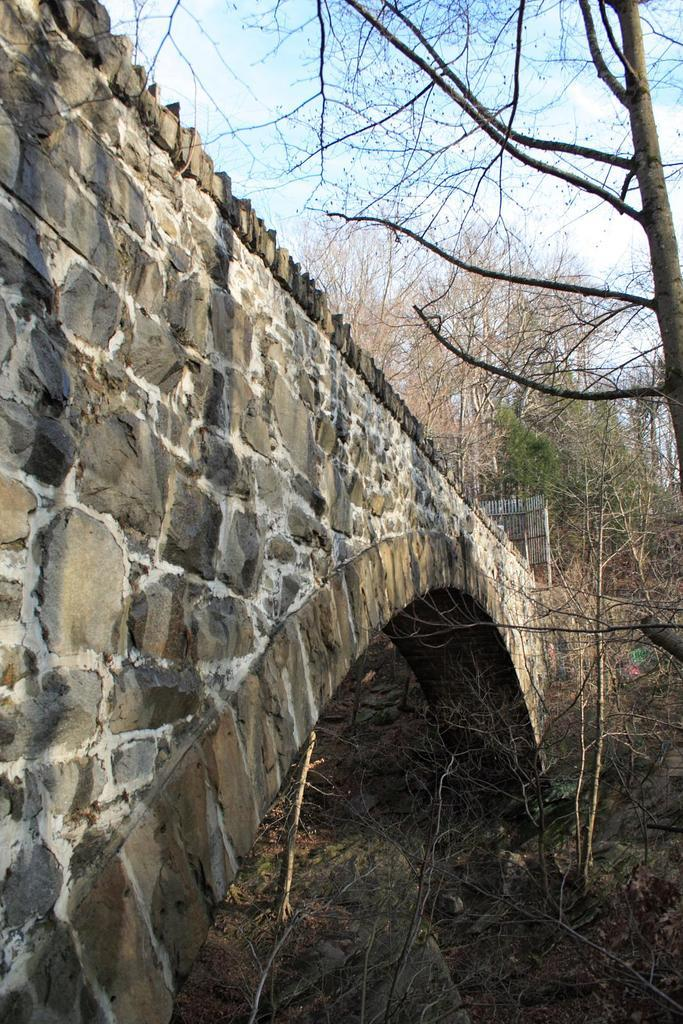What type of vegetation can be seen in the image? There are trees in the image. What can be seen beneath the trees? The ground is visible in the image. Are there any objects on the ground? Yes, there are objects on the ground. What structure can be seen crossing over a body of water in the image? There is a bridge in the image. What is visible above the trees and objects in the image? The sky is visible in the image. Is there any barrier or enclosure visible in the image? Yes, there is a fence in the image. What type of corn can be heard rustling in the image? There is no corn present in the image, and therefore no sound of rustling can be heard. Can you describe the walkway or path in the image? There is no specific walkway or path mentioned in the provided facts, but there is a bridge visible in the image. 